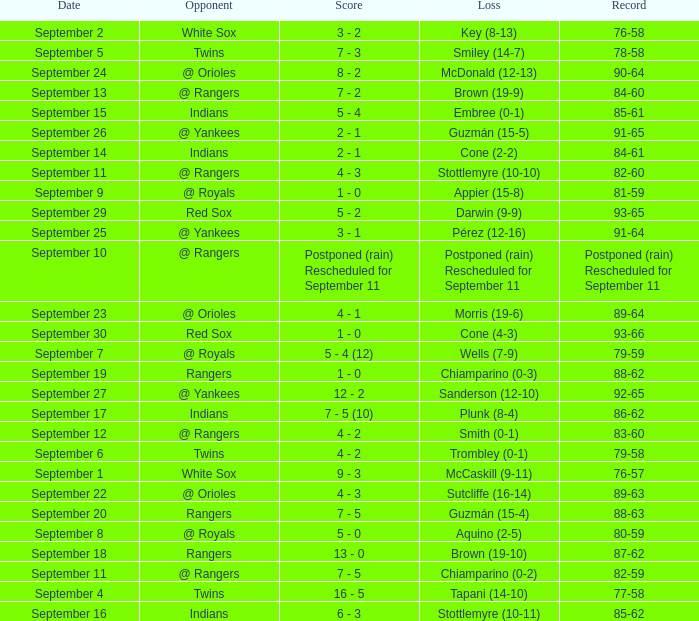What is the score from September 15 that has the Indians as the opponent? 5 - 4. 